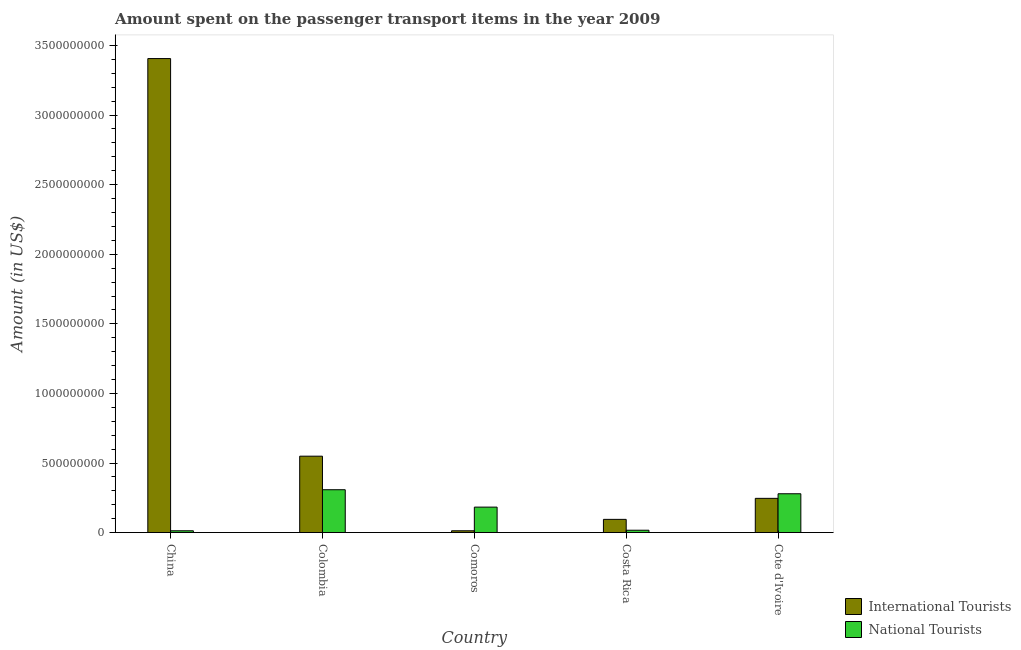How many groups of bars are there?
Your response must be concise. 5. Are the number of bars per tick equal to the number of legend labels?
Provide a short and direct response. Yes. Are the number of bars on each tick of the X-axis equal?
Provide a short and direct response. Yes. How many bars are there on the 5th tick from the left?
Offer a terse response. 2. What is the label of the 5th group of bars from the left?
Your response must be concise. Cote d'Ivoire. In how many cases, is the number of bars for a given country not equal to the number of legend labels?
Make the answer very short. 0. What is the amount spent on transport items of international tourists in China?
Offer a very short reply. 3.41e+09. Across all countries, what is the maximum amount spent on transport items of international tourists?
Provide a short and direct response. 3.41e+09. Across all countries, what is the minimum amount spent on transport items of national tourists?
Offer a terse response. 1.30e+07. In which country was the amount spent on transport items of international tourists minimum?
Your response must be concise. Comoros. What is the total amount spent on transport items of international tourists in the graph?
Offer a terse response. 4.31e+09. What is the difference between the amount spent on transport items of international tourists in China and that in Comoros?
Keep it short and to the point. 3.39e+09. What is the difference between the amount spent on transport items of national tourists in Costa Rica and the amount spent on transport items of international tourists in Cote d'Ivoire?
Your response must be concise. -2.29e+08. What is the average amount spent on transport items of national tourists per country?
Keep it short and to the point. 1.60e+08. What is the difference between the amount spent on transport items of national tourists and amount spent on transport items of international tourists in China?
Your response must be concise. -3.39e+09. What is the ratio of the amount spent on transport items of national tourists in China to that in Colombia?
Give a very brief answer. 0.04. Is the amount spent on transport items of international tourists in China less than that in Comoros?
Your response must be concise. No. Is the difference between the amount spent on transport items of international tourists in Colombia and Cote d'Ivoire greater than the difference between the amount spent on transport items of national tourists in Colombia and Cote d'Ivoire?
Your response must be concise. Yes. What is the difference between the highest and the second highest amount spent on transport items of international tourists?
Provide a succinct answer. 2.86e+09. What is the difference between the highest and the lowest amount spent on transport items of national tourists?
Offer a very short reply. 2.95e+08. Is the sum of the amount spent on transport items of national tourists in Colombia and Comoros greater than the maximum amount spent on transport items of international tourists across all countries?
Give a very brief answer. No. What does the 2nd bar from the left in Cote d'Ivoire represents?
Provide a succinct answer. National Tourists. What does the 2nd bar from the right in Cote d'Ivoire represents?
Provide a short and direct response. International Tourists. How many bars are there?
Give a very brief answer. 10. Are all the bars in the graph horizontal?
Offer a very short reply. No. Are the values on the major ticks of Y-axis written in scientific E-notation?
Provide a succinct answer. No. How many legend labels are there?
Offer a very short reply. 2. How are the legend labels stacked?
Offer a very short reply. Vertical. What is the title of the graph?
Your answer should be compact. Amount spent on the passenger transport items in the year 2009. What is the label or title of the X-axis?
Offer a very short reply. Country. What is the label or title of the Y-axis?
Provide a succinct answer. Amount (in US$). What is the Amount (in US$) in International Tourists in China?
Offer a very short reply. 3.41e+09. What is the Amount (in US$) in National Tourists in China?
Ensure brevity in your answer.  1.30e+07. What is the Amount (in US$) in International Tourists in Colombia?
Make the answer very short. 5.49e+08. What is the Amount (in US$) of National Tourists in Colombia?
Keep it short and to the point. 3.08e+08. What is the Amount (in US$) in International Tourists in Comoros?
Offer a terse response. 1.30e+07. What is the Amount (in US$) in National Tourists in Comoros?
Offer a very short reply. 1.83e+08. What is the Amount (in US$) of International Tourists in Costa Rica?
Make the answer very short. 9.50e+07. What is the Amount (in US$) in National Tourists in Costa Rica?
Ensure brevity in your answer.  1.70e+07. What is the Amount (in US$) of International Tourists in Cote d'Ivoire?
Provide a succinct answer. 2.46e+08. What is the Amount (in US$) in National Tourists in Cote d'Ivoire?
Provide a succinct answer. 2.79e+08. Across all countries, what is the maximum Amount (in US$) in International Tourists?
Your answer should be very brief. 3.41e+09. Across all countries, what is the maximum Amount (in US$) of National Tourists?
Your answer should be very brief. 3.08e+08. Across all countries, what is the minimum Amount (in US$) in International Tourists?
Provide a short and direct response. 1.30e+07. Across all countries, what is the minimum Amount (in US$) of National Tourists?
Your response must be concise. 1.30e+07. What is the total Amount (in US$) in International Tourists in the graph?
Keep it short and to the point. 4.31e+09. What is the total Amount (in US$) in National Tourists in the graph?
Ensure brevity in your answer.  8.00e+08. What is the difference between the Amount (in US$) in International Tourists in China and that in Colombia?
Your answer should be compact. 2.86e+09. What is the difference between the Amount (in US$) of National Tourists in China and that in Colombia?
Provide a succinct answer. -2.95e+08. What is the difference between the Amount (in US$) of International Tourists in China and that in Comoros?
Make the answer very short. 3.39e+09. What is the difference between the Amount (in US$) of National Tourists in China and that in Comoros?
Your answer should be compact. -1.70e+08. What is the difference between the Amount (in US$) of International Tourists in China and that in Costa Rica?
Offer a terse response. 3.31e+09. What is the difference between the Amount (in US$) of International Tourists in China and that in Cote d'Ivoire?
Provide a succinct answer. 3.16e+09. What is the difference between the Amount (in US$) of National Tourists in China and that in Cote d'Ivoire?
Provide a succinct answer. -2.66e+08. What is the difference between the Amount (in US$) of International Tourists in Colombia and that in Comoros?
Keep it short and to the point. 5.36e+08. What is the difference between the Amount (in US$) of National Tourists in Colombia and that in Comoros?
Ensure brevity in your answer.  1.25e+08. What is the difference between the Amount (in US$) of International Tourists in Colombia and that in Costa Rica?
Your answer should be very brief. 4.54e+08. What is the difference between the Amount (in US$) of National Tourists in Colombia and that in Costa Rica?
Your answer should be very brief. 2.91e+08. What is the difference between the Amount (in US$) in International Tourists in Colombia and that in Cote d'Ivoire?
Offer a terse response. 3.03e+08. What is the difference between the Amount (in US$) in National Tourists in Colombia and that in Cote d'Ivoire?
Ensure brevity in your answer.  2.90e+07. What is the difference between the Amount (in US$) in International Tourists in Comoros and that in Costa Rica?
Give a very brief answer. -8.20e+07. What is the difference between the Amount (in US$) of National Tourists in Comoros and that in Costa Rica?
Ensure brevity in your answer.  1.66e+08. What is the difference between the Amount (in US$) of International Tourists in Comoros and that in Cote d'Ivoire?
Ensure brevity in your answer.  -2.33e+08. What is the difference between the Amount (in US$) in National Tourists in Comoros and that in Cote d'Ivoire?
Your answer should be compact. -9.60e+07. What is the difference between the Amount (in US$) of International Tourists in Costa Rica and that in Cote d'Ivoire?
Your answer should be compact. -1.51e+08. What is the difference between the Amount (in US$) of National Tourists in Costa Rica and that in Cote d'Ivoire?
Your response must be concise. -2.62e+08. What is the difference between the Amount (in US$) in International Tourists in China and the Amount (in US$) in National Tourists in Colombia?
Give a very brief answer. 3.10e+09. What is the difference between the Amount (in US$) in International Tourists in China and the Amount (in US$) in National Tourists in Comoros?
Your response must be concise. 3.22e+09. What is the difference between the Amount (in US$) in International Tourists in China and the Amount (in US$) in National Tourists in Costa Rica?
Make the answer very short. 3.39e+09. What is the difference between the Amount (in US$) in International Tourists in China and the Amount (in US$) in National Tourists in Cote d'Ivoire?
Offer a very short reply. 3.13e+09. What is the difference between the Amount (in US$) in International Tourists in Colombia and the Amount (in US$) in National Tourists in Comoros?
Provide a succinct answer. 3.66e+08. What is the difference between the Amount (in US$) in International Tourists in Colombia and the Amount (in US$) in National Tourists in Costa Rica?
Make the answer very short. 5.32e+08. What is the difference between the Amount (in US$) of International Tourists in Colombia and the Amount (in US$) of National Tourists in Cote d'Ivoire?
Your answer should be very brief. 2.70e+08. What is the difference between the Amount (in US$) in International Tourists in Comoros and the Amount (in US$) in National Tourists in Costa Rica?
Make the answer very short. -4.00e+06. What is the difference between the Amount (in US$) of International Tourists in Comoros and the Amount (in US$) of National Tourists in Cote d'Ivoire?
Offer a very short reply. -2.66e+08. What is the difference between the Amount (in US$) of International Tourists in Costa Rica and the Amount (in US$) of National Tourists in Cote d'Ivoire?
Provide a short and direct response. -1.84e+08. What is the average Amount (in US$) of International Tourists per country?
Provide a succinct answer. 8.62e+08. What is the average Amount (in US$) in National Tourists per country?
Your response must be concise. 1.60e+08. What is the difference between the Amount (in US$) in International Tourists and Amount (in US$) in National Tourists in China?
Your answer should be very brief. 3.39e+09. What is the difference between the Amount (in US$) of International Tourists and Amount (in US$) of National Tourists in Colombia?
Keep it short and to the point. 2.41e+08. What is the difference between the Amount (in US$) in International Tourists and Amount (in US$) in National Tourists in Comoros?
Your answer should be compact. -1.70e+08. What is the difference between the Amount (in US$) of International Tourists and Amount (in US$) of National Tourists in Costa Rica?
Make the answer very short. 7.80e+07. What is the difference between the Amount (in US$) of International Tourists and Amount (in US$) of National Tourists in Cote d'Ivoire?
Provide a short and direct response. -3.30e+07. What is the ratio of the Amount (in US$) of International Tourists in China to that in Colombia?
Make the answer very short. 6.2. What is the ratio of the Amount (in US$) in National Tourists in China to that in Colombia?
Make the answer very short. 0.04. What is the ratio of the Amount (in US$) in International Tourists in China to that in Comoros?
Provide a succinct answer. 262. What is the ratio of the Amount (in US$) of National Tourists in China to that in Comoros?
Your answer should be very brief. 0.07. What is the ratio of the Amount (in US$) of International Tourists in China to that in Costa Rica?
Ensure brevity in your answer.  35.85. What is the ratio of the Amount (in US$) of National Tourists in China to that in Costa Rica?
Your response must be concise. 0.76. What is the ratio of the Amount (in US$) in International Tourists in China to that in Cote d'Ivoire?
Ensure brevity in your answer.  13.85. What is the ratio of the Amount (in US$) of National Tourists in China to that in Cote d'Ivoire?
Offer a terse response. 0.05. What is the ratio of the Amount (in US$) in International Tourists in Colombia to that in Comoros?
Offer a terse response. 42.23. What is the ratio of the Amount (in US$) of National Tourists in Colombia to that in Comoros?
Your response must be concise. 1.68. What is the ratio of the Amount (in US$) in International Tourists in Colombia to that in Costa Rica?
Ensure brevity in your answer.  5.78. What is the ratio of the Amount (in US$) in National Tourists in Colombia to that in Costa Rica?
Keep it short and to the point. 18.12. What is the ratio of the Amount (in US$) of International Tourists in Colombia to that in Cote d'Ivoire?
Offer a very short reply. 2.23. What is the ratio of the Amount (in US$) in National Tourists in Colombia to that in Cote d'Ivoire?
Provide a short and direct response. 1.1. What is the ratio of the Amount (in US$) of International Tourists in Comoros to that in Costa Rica?
Provide a short and direct response. 0.14. What is the ratio of the Amount (in US$) of National Tourists in Comoros to that in Costa Rica?
Your response must be concise. 10.76. What is the ratio of the Amount (in US$) in International Tourists in Comoros to that in Cote d'Ivoire?
Ensure brevity in your answer.  0.05. What is the ratio of the Amount (in US$) in National Tourists in Comoros to that in Cote d'Ivoire?
Your answer should be very brief. 0.66. What is the ratio of the Amount (in US$) of International Tourists in Costa Rica to that in Cote d'Ivoire?
Offer a terse response. 0.39. What is the ratio of the Amount (in US$) of National Tourists in Costa Rica to that in Cote d'Ivoire?
Make the answer very short. 0.06. What is the difference between the highest and the second highest Amount (in US$) of International Tourists?
Provide a short and direct response. 2.86e+09. What is the difference between the highest and the second highest Amount (in US$) of National Tourists?
Provide a short and direct response. 2.90e+07. What is the difference between the highest and the lowest Amount (in US$) in International Tourists?
Offer a very short reply. 3.39e+09. What is the difference between the highest and the lowest Amount (in US$) of National Tourists?
Offer a very short reply. 2.95e+08. 